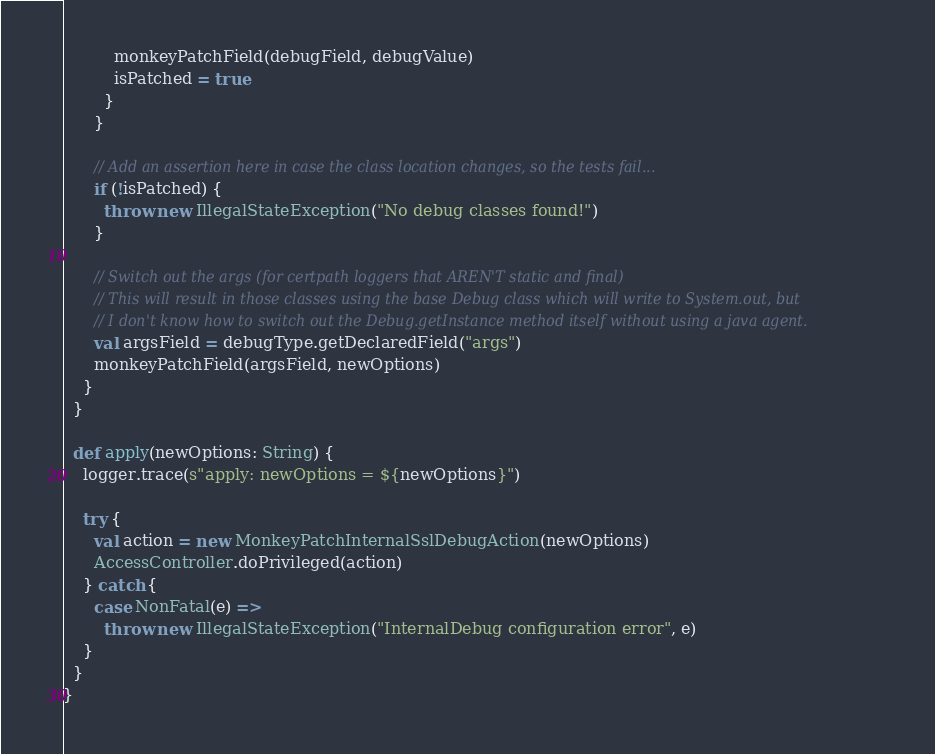Convert code to text. <code><loc_0><loc_0><loc_500><loc_500><_Scala_>          monkeyPatchField(debugField, debugValue)
          isPatched = true
        }
      }

      // Add an assertion here in case the class location changes, so the tests fail...
      if (!isPatched) {
        throw new IllegalStateException("No debug classes found!")
      }

      // Switch out the args (for certpath loggers that AREN'T static and final)
      // This will result in those classes using the base Debug class which will write to System.out, but
      // I don't know how to switch out the Debug.getInstance method itself without using a java agent.
      val argsField = debugType.getDeclaredField("args")
      monkeyPatchField(argsField, newOptions)
    }
  }

  def apply(newOptions: String) {
    logger.trace(s"apply: newOptions = ${newOptions}")

    try {
      val action = new MonkeyPatchInternalSslDebugAction(newOptions)
      AccessController.doPrivileged(action)
    } catch {
      case NonFatal(e) =>
        throw new IllegalStateException("InternalDebug configuration error", e)
    }
  }
}
</code> 